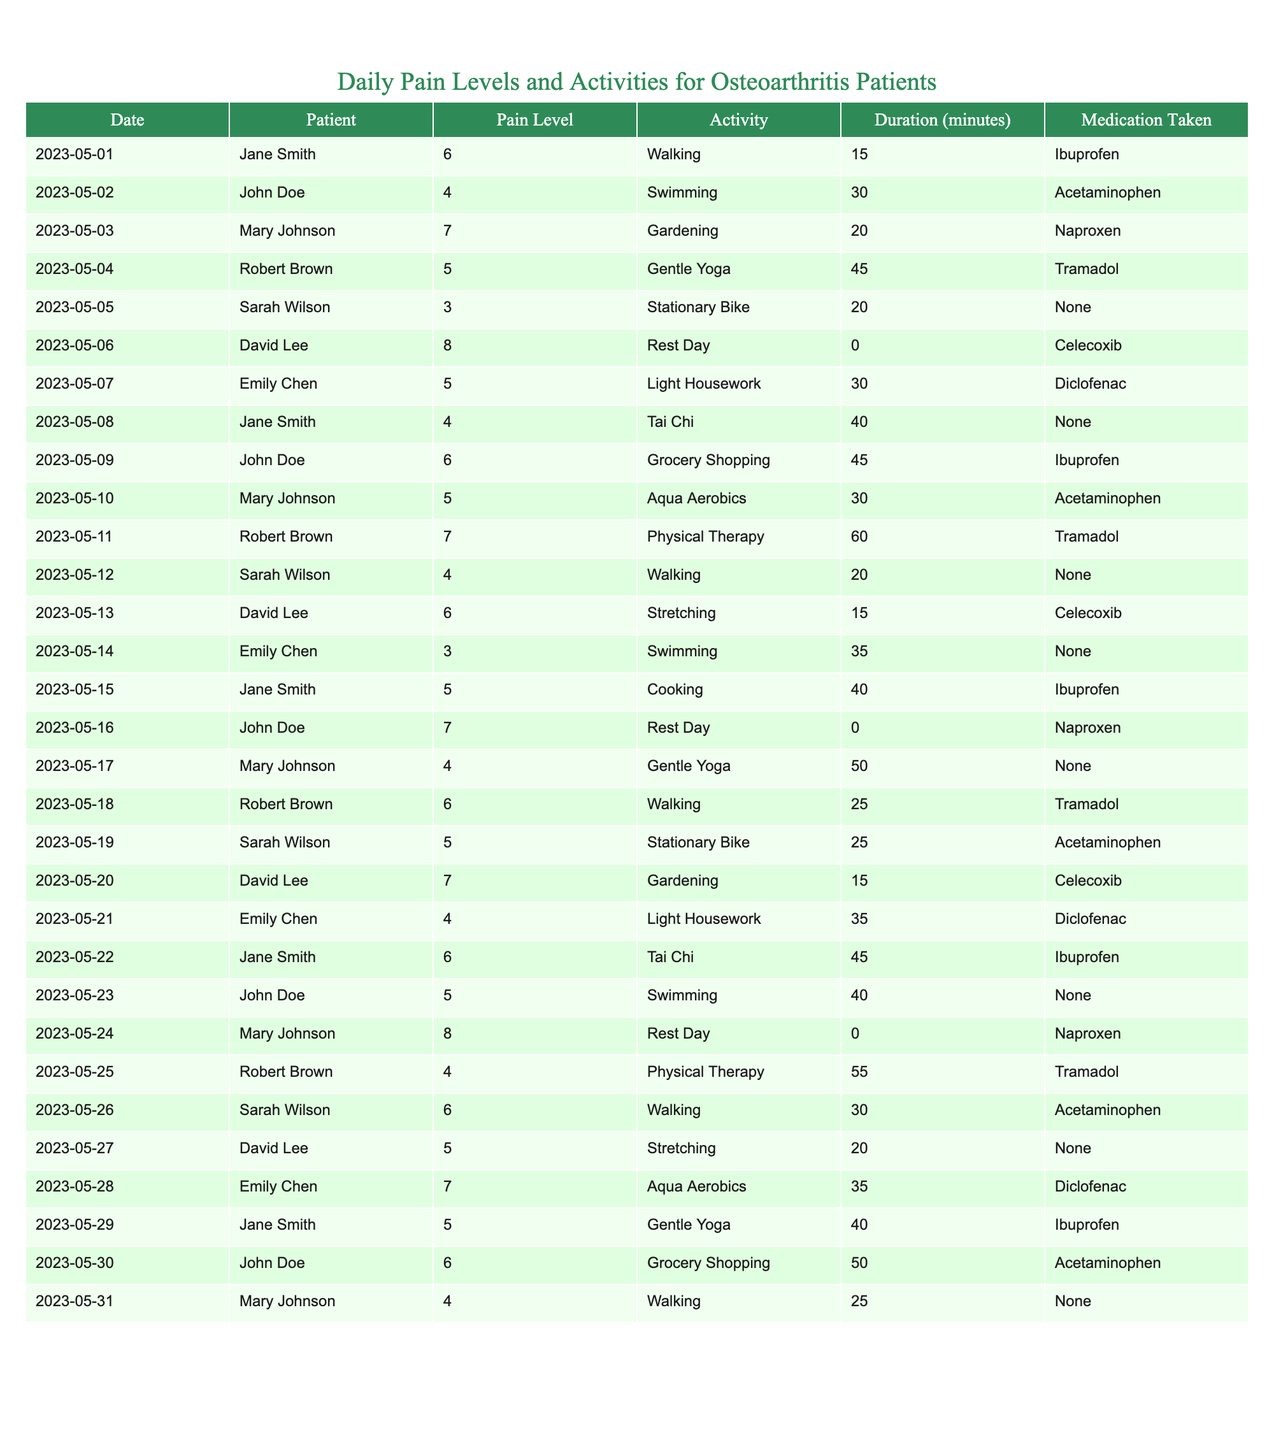What is the highest pain level recorded in the table? The table lists daily pain levels for different patients. Scanning through the "Pain Level" column, the highest value is 8, which occurs on 2023-05-24 for Mary Johnson on a rest day.
Answer: 8 Which patient took medication on May 6th? By looking at the row for May 6th in the table, the patient is David Lee, who took Celecoxib on a rest day.
Answer: David Lee What activities did Sarah Wilson do that had a pain level of 5? Checking the table for Sarah Wilson's entries, two activities show a pain level of 5: Stationary Bike on May 19th and Walking on May 12th.
Answer: Stationary Bike, Walking What is the average pain level for John Doe throughout the month? John Doe's pain levels are 4, 6, 7, 5, and 6 across five days. Adding these values gives a total of 28, and dividing by the number of days (5) results in an average pain level of 5.6.
Answer: 5.6 Did any patient not take any medication during the month? By reviewing the "Medication Taken" column, both Jane Smith and Emily Chen had entries with "None” on multiple occasions, confirming they did not take medication on those days.
Answer: Yes On how many days did Mary Johnson experience a pain level of 6 or higher? Looking through Mary Johnson's entries, she had pain levels of 7, 7, and 8 on three different occasions. So she experienced pain levels of 6 or higher on three days.
Answer: 3 What was the pain level when Robert Brown did physical therapy? Checking the table, Robert Brown had a pain level of 4 when he did physical therapy on May 25th.
Answer: 4 What activity was performed for the longest duration by a patient? The table shows that Robert Brown did physical therapy for 60 minutes, which is the longest duration listed among activities.
Answer: Physical Therapy, 60 minutes Did Sarah Wilson participate in any activities with a pain level of 3? Upon examining Sarah Wilson's entries, she only shows pain levels of 3 and above, confirming she did not engage in any activities with a pain level of 3 or lower.
Answer: No 